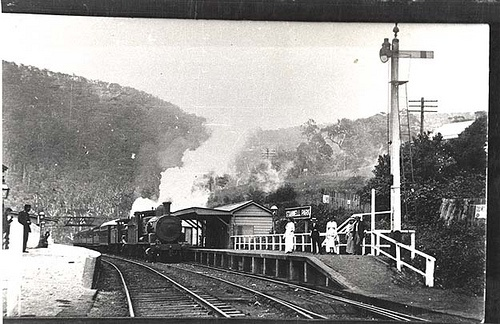Describe the objects in this image and their specific colors. I can see train in lightgray, black, gray, darkgray, and white tones, people in lightgray, white, black, darkgray, and gray tones, people in lightgray, black, gray, and darkgray tones, people in lightgray, white, black, darkgray, and gray tones, and people in lightgray, black, gray, darkgray, and white tones in this image. 